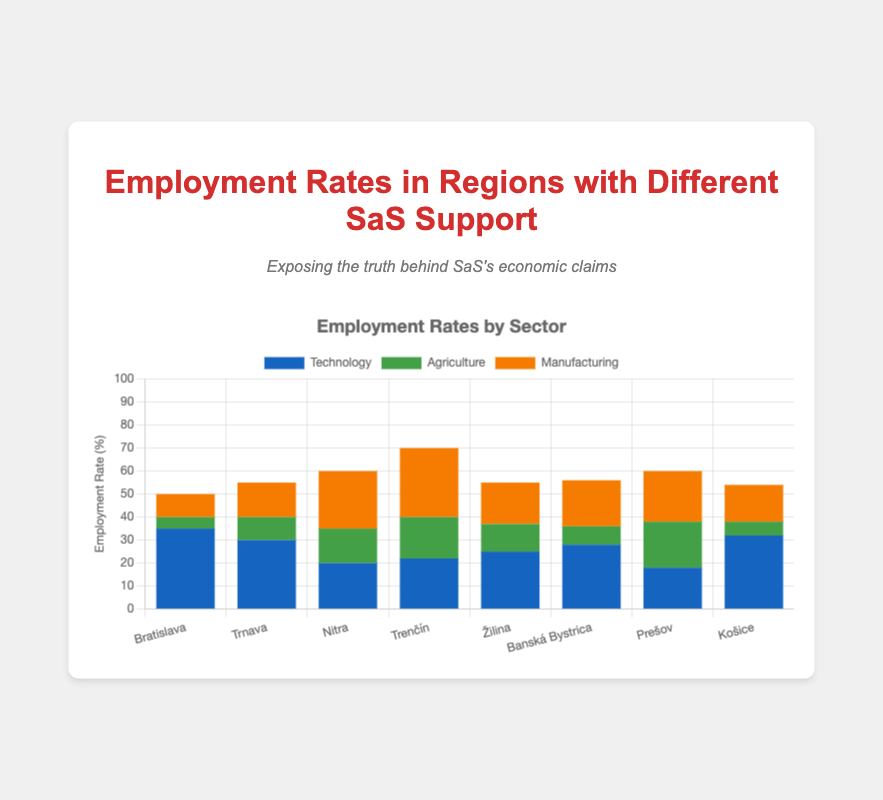Which region has the highest employment rate in the Technology sector? The chart shows the Technology employment rates by region, and Bratislava has the tallest bar in the blue color representing the Technology sector
Answer: Bratislava What's the total employment rate for Manufacturing in regions with high SaS support? The chart shows the Manufacturing employment rates in high SaS support regions: Bratislava (10), Trnava (15), Banská Bystrica (20), and Košice (16). Summing these gives 10 + 15 + 20 + 16 = 61
Answer: 61 Which region with high SaS support has the lowest employment rate in Agriculture? The chart shows the Agriculture employment rates in high SaS support regions: Bratislava (5), Trnava (10), Banská Bystrica (8), and Košice (6). The smallest value is 5 for Bratislava
Answer: Bratislava What is the average employment rate in the Technology sector in regions with low SaS support? The Technology employment rates in regions with low SaS support are Nitra (20), Trenčín (22), Žilina (25), and Prešov (18). The average is (20 + 22 + 25 + 18) / 4 = 21.25
Answer: 21.25 Compare the total employment rate in Agriculture between regions with high and low SaS support. Which is higher? The total Agriculture employment rate in high SaS support regions is Bratislava (5) + Trnava (10) + Banská Bystrica (8) + Košice (6) = 29. In low SaS support regions, it's Nitra (15) + Trenčín (18) + Žilina (12) + Prešov (20) = 65. Thus, low SaS support regions have a higher total
Answer: Low SaS support Which region has the highest overall employment rate considering all sectors? Adding the employment rates across all sectors for each region, Bratislava has 35 + 5 + 10 = 50, Trnava has 30 + 10 + 15 = 55, Nitra has 20 + 15 + 25 = 60, Trenčín has 22 + 18 + 30 = 70, Žilina has 25 + 12 + 18 = 55, Banská Bystrica has 28 + 8 + 20 = 56, Prešov has 18 + 20 + 22 = 60, and Košice has 32 + 6 + 16 = 54. Trenčín has the highest total
Answer: Trenčín What is the difference in the Technology employment rate between Trnava and Nitra? The chart shows that Trnava has a Technology employment rate of 30 and Nitra has 20. The difference is 30 - 20 = 10
Answer: 10 Which sector has the most consistent employment rates across all regions? Visually comparing the bars representing different sectors (blue for Technology, green for Agriculture, orange for Manufacturing), Agriculture has the most similar heights across regions, indicating more consistent rates
Answer: Agriculture 